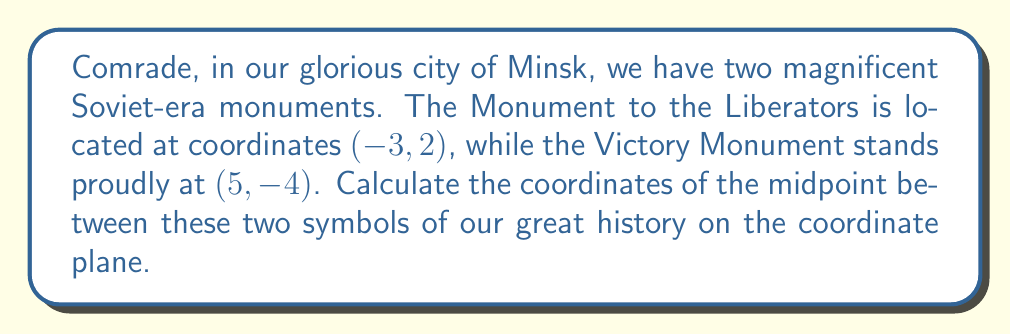Can you answer this question? To find the midpoint between two points on a coordinate plane, we use the midpoint formula:

$$ \text{Midpoint} = \left(\frac{x_1 + x_2}{2}, \frac{y_1 + y_2}{2}\right) $$

Where $(x_1, y_1)$ are the coordinates of the first point and $(x_2, y_2)$ are the coordinates of the second point.

For our monuments:
- Monument to the Liberators: $(-3, 2)$
- Victory Monument: $(5, -4)$

Let's substitute these values into the formula:

$$ \text{Midpoint} = \left(\frac{-3 + 5}{2}, \frac{2 + (-4)}{2}\right) $$

Now, let's calculate each coordinate:

For the x-coordinate:
$$ \frac{-3 + 5}{2} = \frac{2}{2} = 1 $$

For the y-coordinate:
$$ \frac{2 + (-4)}{2} = \frac{-2}{2} = -1 $$

Therefore, the midpoint between our two grand monuments is $(1, -1)$.
Answer: $(1, -1)$ 